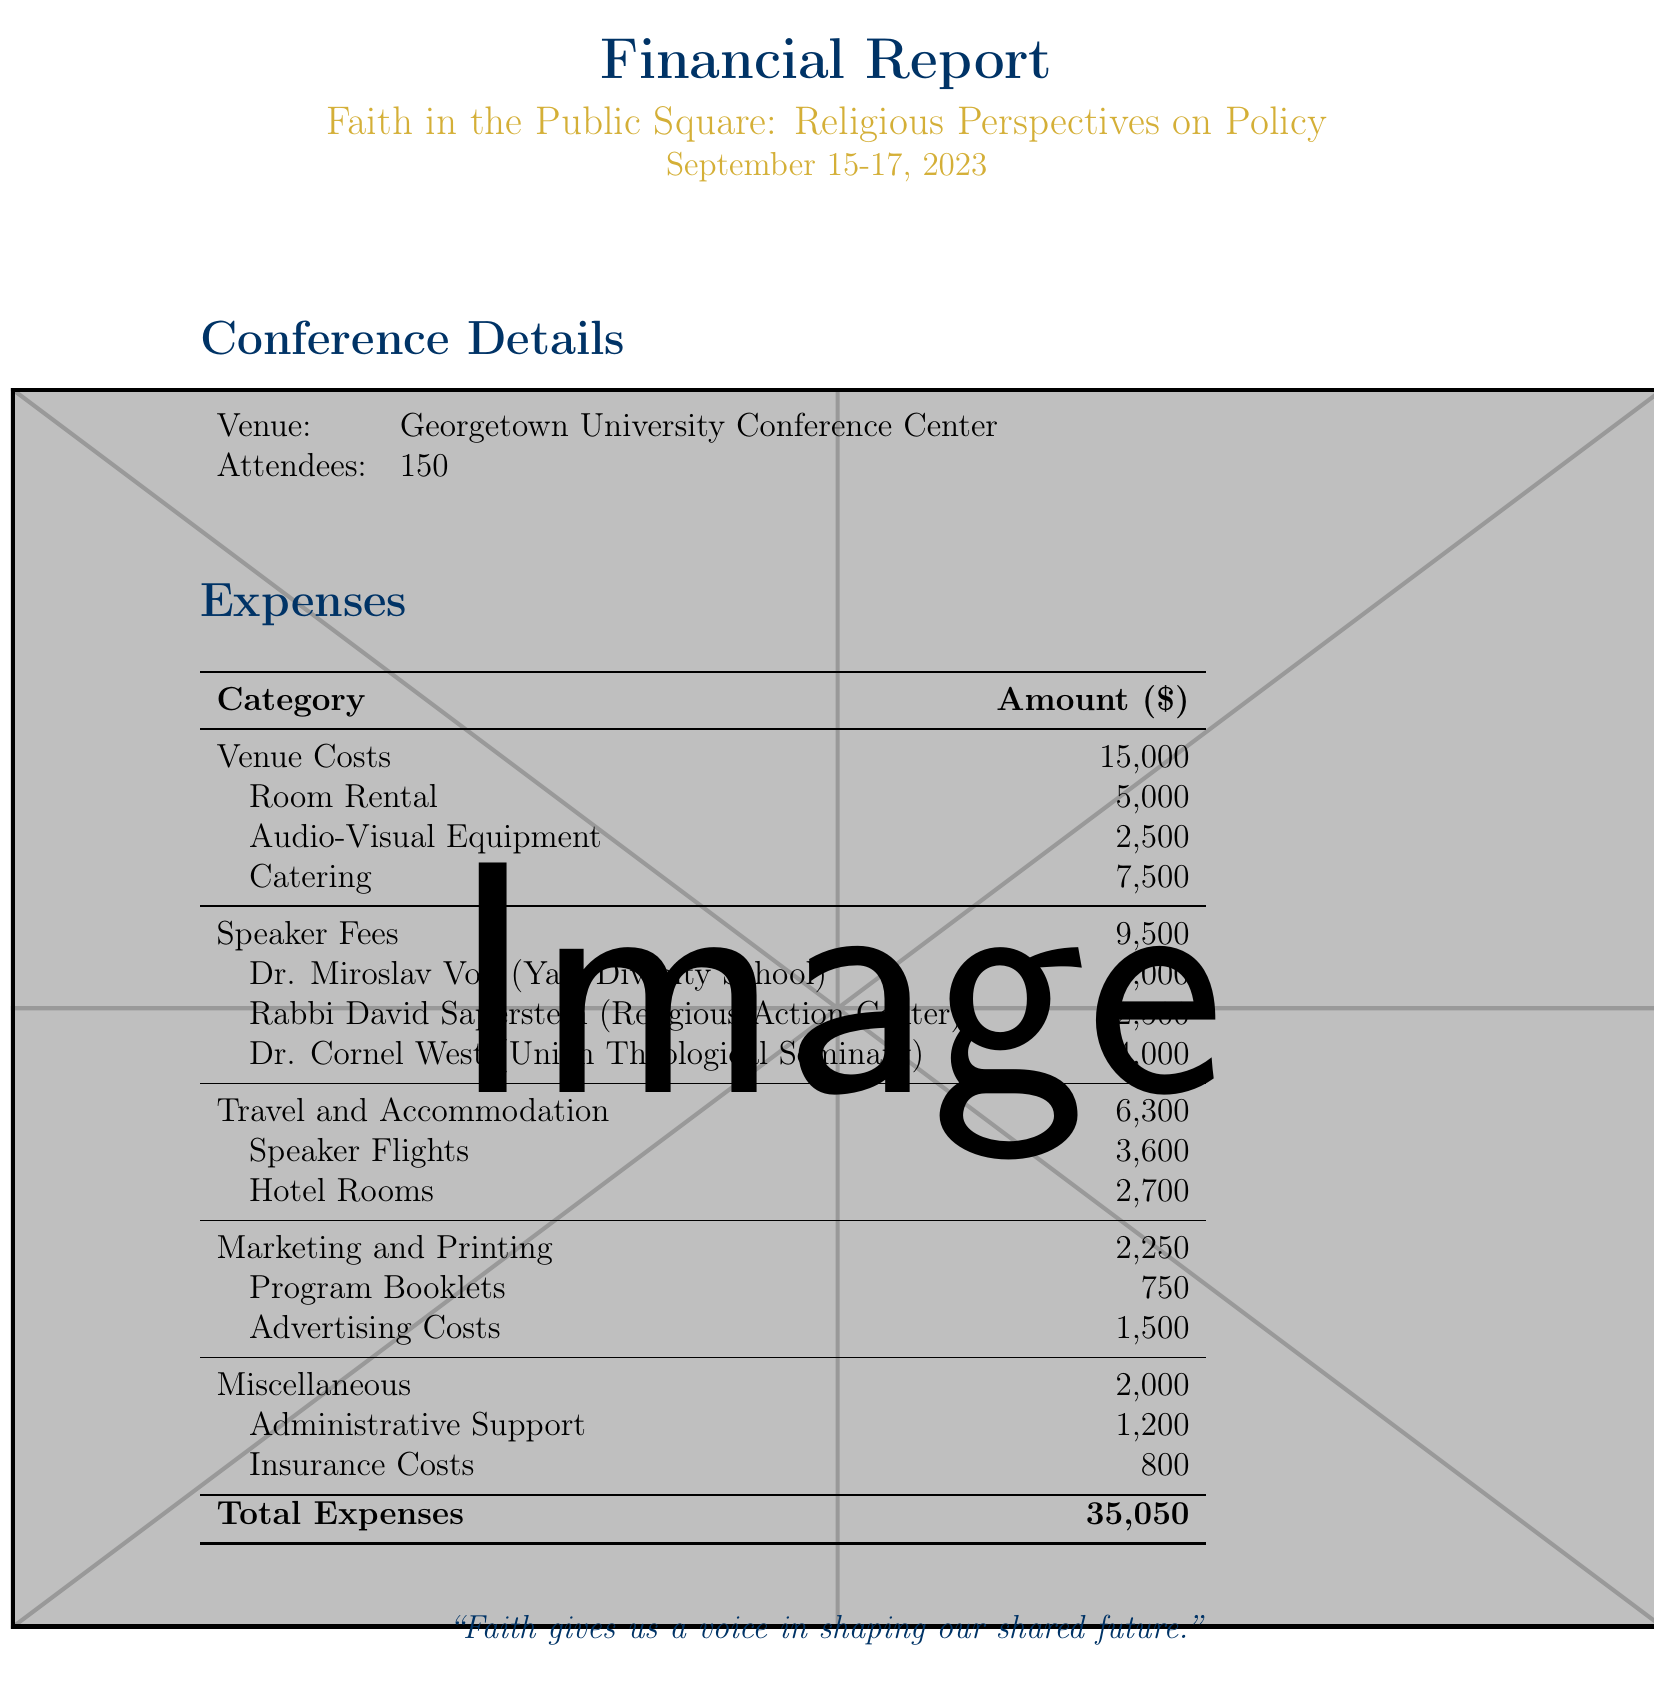what is the total amount of venue costs? The venue costs are detailed in the document as room rental, audio-visual equipment, and catering, totaling $5000 + $2500 + $7500 = $15000.
Answer: $15000 who is the speaker affiliated with Yale Divinity School? The document lists Dr. Miroslav Volf as the speaker from Yale Divinity School.
Answer: Dr. Miroslav Volf what is the fee for Dr. Cornel West? The document states that Dr. Cornel West charges a fee of $4000.
Answer: $4000 how much was spent on marketing and printing? The marketing and printing expenses are broken down and total $750 + $1500 = $2250 according to the document.
Answer: $2250 what is the total expense for the conference? The document provides the total expenses at the end, summing up all categories to $35050.
Answer: $35050 how many attendees were present at the conference? The document specifies that there were 150 attendees at the conference.
Answer: 150 what venue was used for the conference? The document identifies Georgetown University Conference Center as the venue used for the conference.
Answer: Georgetown University Conference Center what are miscellaneous expenses reported in the document? The document lists administrative support and insurance costs as miscellaneous expenses.
Answer: Administrative Support and Insurance Costs 